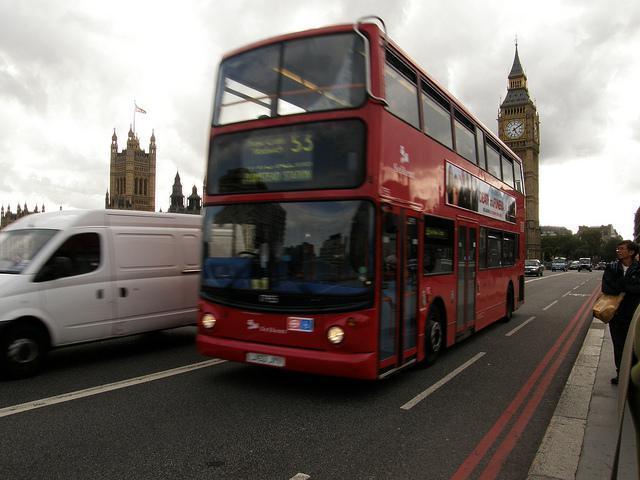How many lights are on the front of the bus?
Give a very brief answer. 2. How many cats with green eyes are there?
Give a very brief answer. 0. 